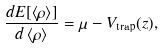Convert formula to latex. <formula><loc_0><loc_0><loc_500><loc_500>\frac { d E [ \left \langle \rho \right \rangle ] } { d \left \langle \rho \right \rangle } = \mu - V _ { \text {trap} } ( z ) ,</formula> 